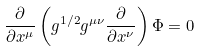Convert formula to latex. <formula><loc_0><loc_0><loc_500><loc_500>\frac { \partial } { \partial x ^ { \mu } } \left ( g ^ { 1 / 2 } g ^ { \mu \nu } \frac { \partial } { \partial x ^ { \nu } } \right ) \Phi = 0</formula> 